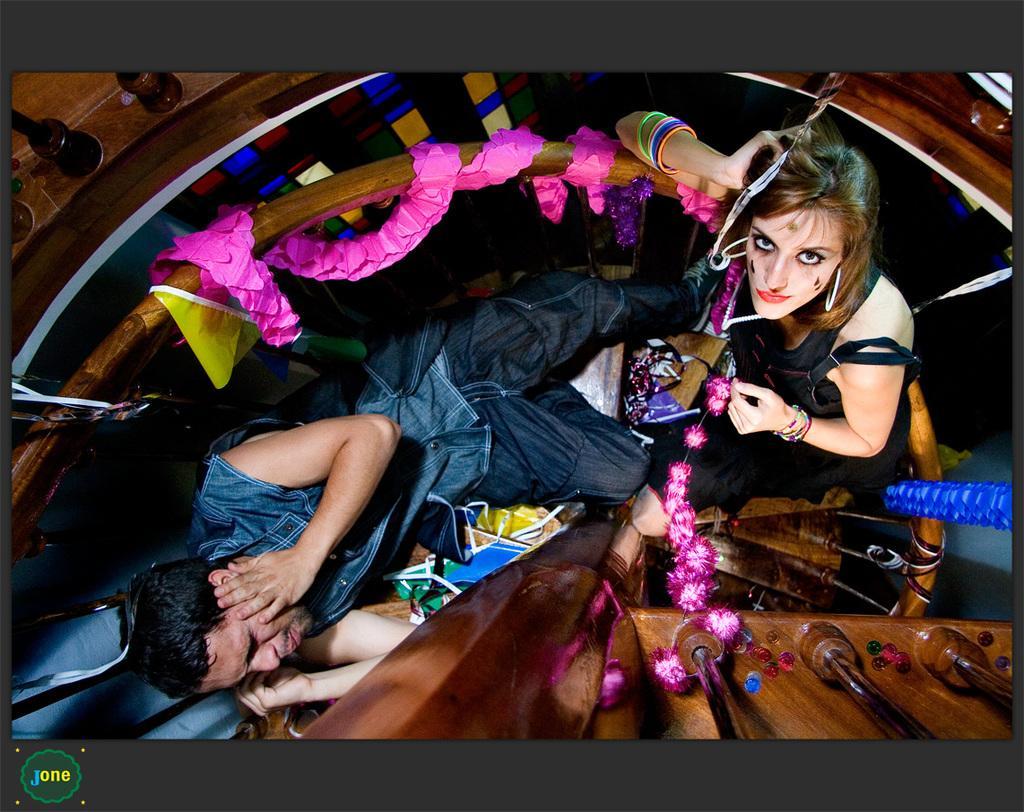Please provide a concise description of this image. In this picture there is a man wearing blue color shirt is lying on the wooden spiral steps. Beside there is a woman wearing black dress smiling and giving a pose in the photograph. 